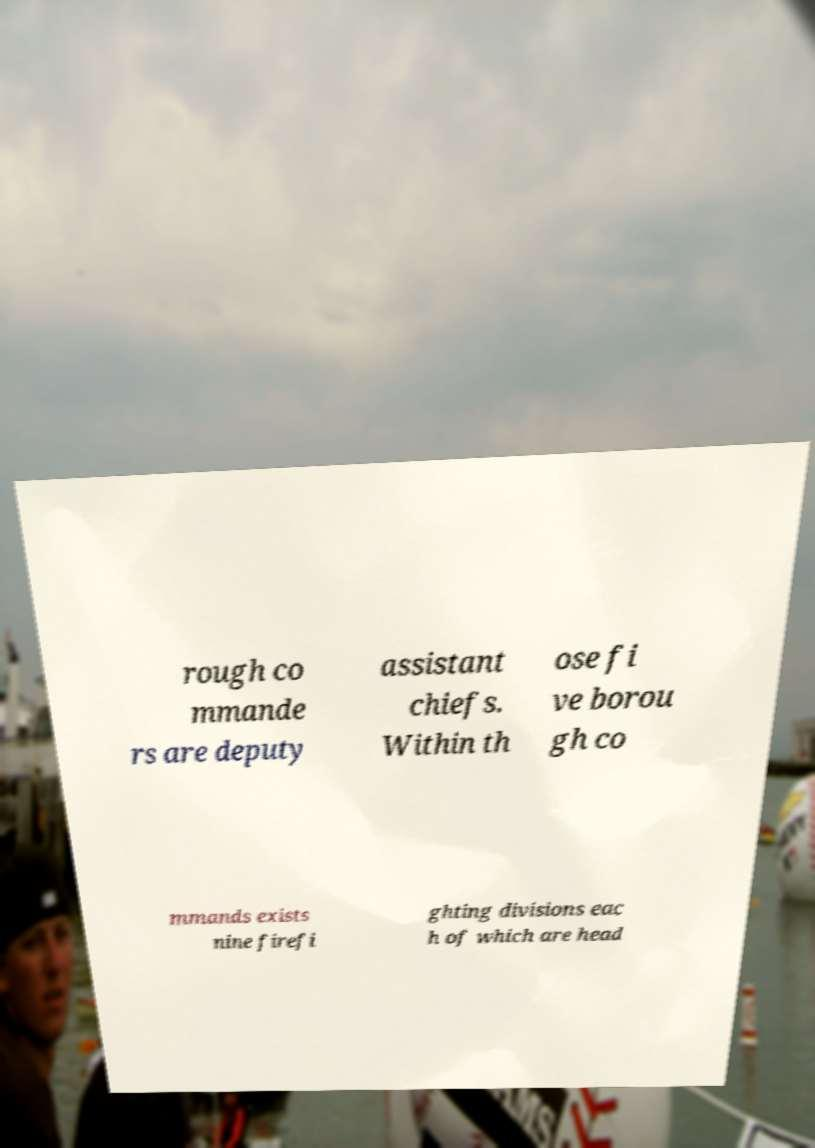There's text embedded in this image that I need extracted. Can you transcribe it verbatim? rough co mmande rs are deputy assistant chiefs. Within th ose fi ve borou gh co mmands exists nine firefi ghting divisions eac h of which are head 